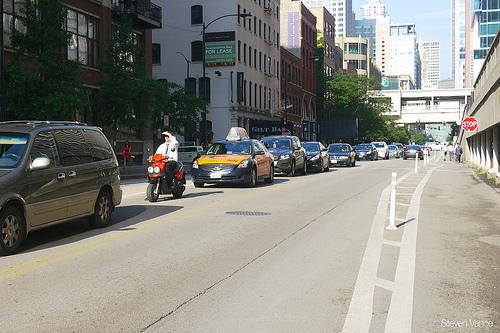What color is the brick building seen in this image, and how tall is it? The brick building is red and appears to be rather tall. Provide a brief description of the image, including the main landmarks. A busy city street with traffic, people walking on the sidewalk, a red and white stop sign, and buildings in the background. Count the number of people visible near the street. There are at least five people walking near the street. Name two types of vehicles that are visible in the image. Grey minivan and yellow and black taxi cab. How many modes of transportation can be seen in the image, and what are they? Four modes of transportation: a red scooter, a grey minivan, a yellow and black taxi cab, and an orange scooter. What is the main subject of this picture performing? A man riding a red scooter and shielding his eyes from the sun. What is the color and activity of the woman walking on the sidewalk? She is dressed in red and is walking along the sidewalk. Mention any two items shown in the image that are hanging or mounted on the buildings. A green and white sign and a for lease sign are mounted on the buildings. What architectural feature connects two buildings in the picture? A pedestrian walkway bridge connects two buildings. Identify the color and shape of the sign in the image. The sign is red and white and has an octagonal shape. 